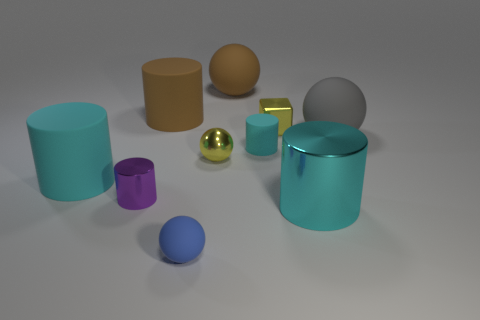Is there a small metallic object that is in front of the big cylinder right of the tiny cylinder that is behind the large cyan matte thing?
Offer a terse response. No. There is a tiny cyan thing that is the same shape as the large cyan matte thing; what is its material?
Make the answer very short. Rubber. Is there anything else that is made of the same material as the yellow block?
Give a very brief answer. Yes. How many blocks are small yellow things or cyan rubber objects?
Provide a succinct answer. 1. Do the matte sphere behind the gray matte ball and the metal cylinder on the right side of the large brown cylinder have the same size?
Offer a terse response. Yes. What is the material of the yellow ball that is in front of the brown thing that is on the left side of the yellow shiny sphere?
Provide a succinct answer. Metal. Is the number of tiny shiny cylinders that are to the right of the blue thing less than the number of large metal cylinders?
Give a very brief answer. Yes. The big thing that is made of the same material as the tiny yellow ball is what shape?
Your response must be concise. Cylinder. What number of other things are the same shape as the big metallic thing?
Offer a very short reply. 4. What number of cyan objects are small metal cylinders or big metallic cylinders?
Make the answer very short. 1. 